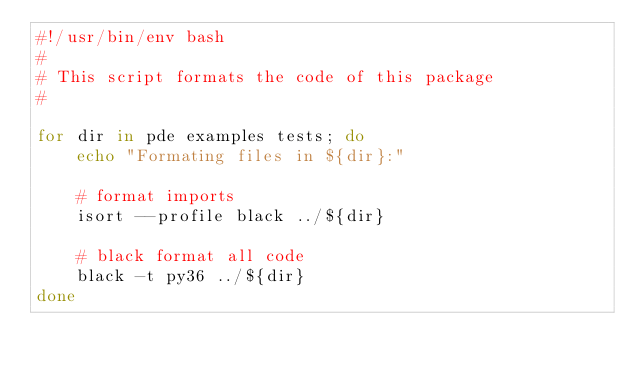Convert code to text. <code><loc_0><loc_0><loc_500><loc_500><_Bash_>#!/usr/bin/env bash
#
# This script formats the code of this package
#

for dir in pde examples tests; do
    echo "Formating files in ${dir}:"

    # format imports
    isort --profile black ../${dir}

    # black format all code
    black -t py36 ../${dir}
done</code> 